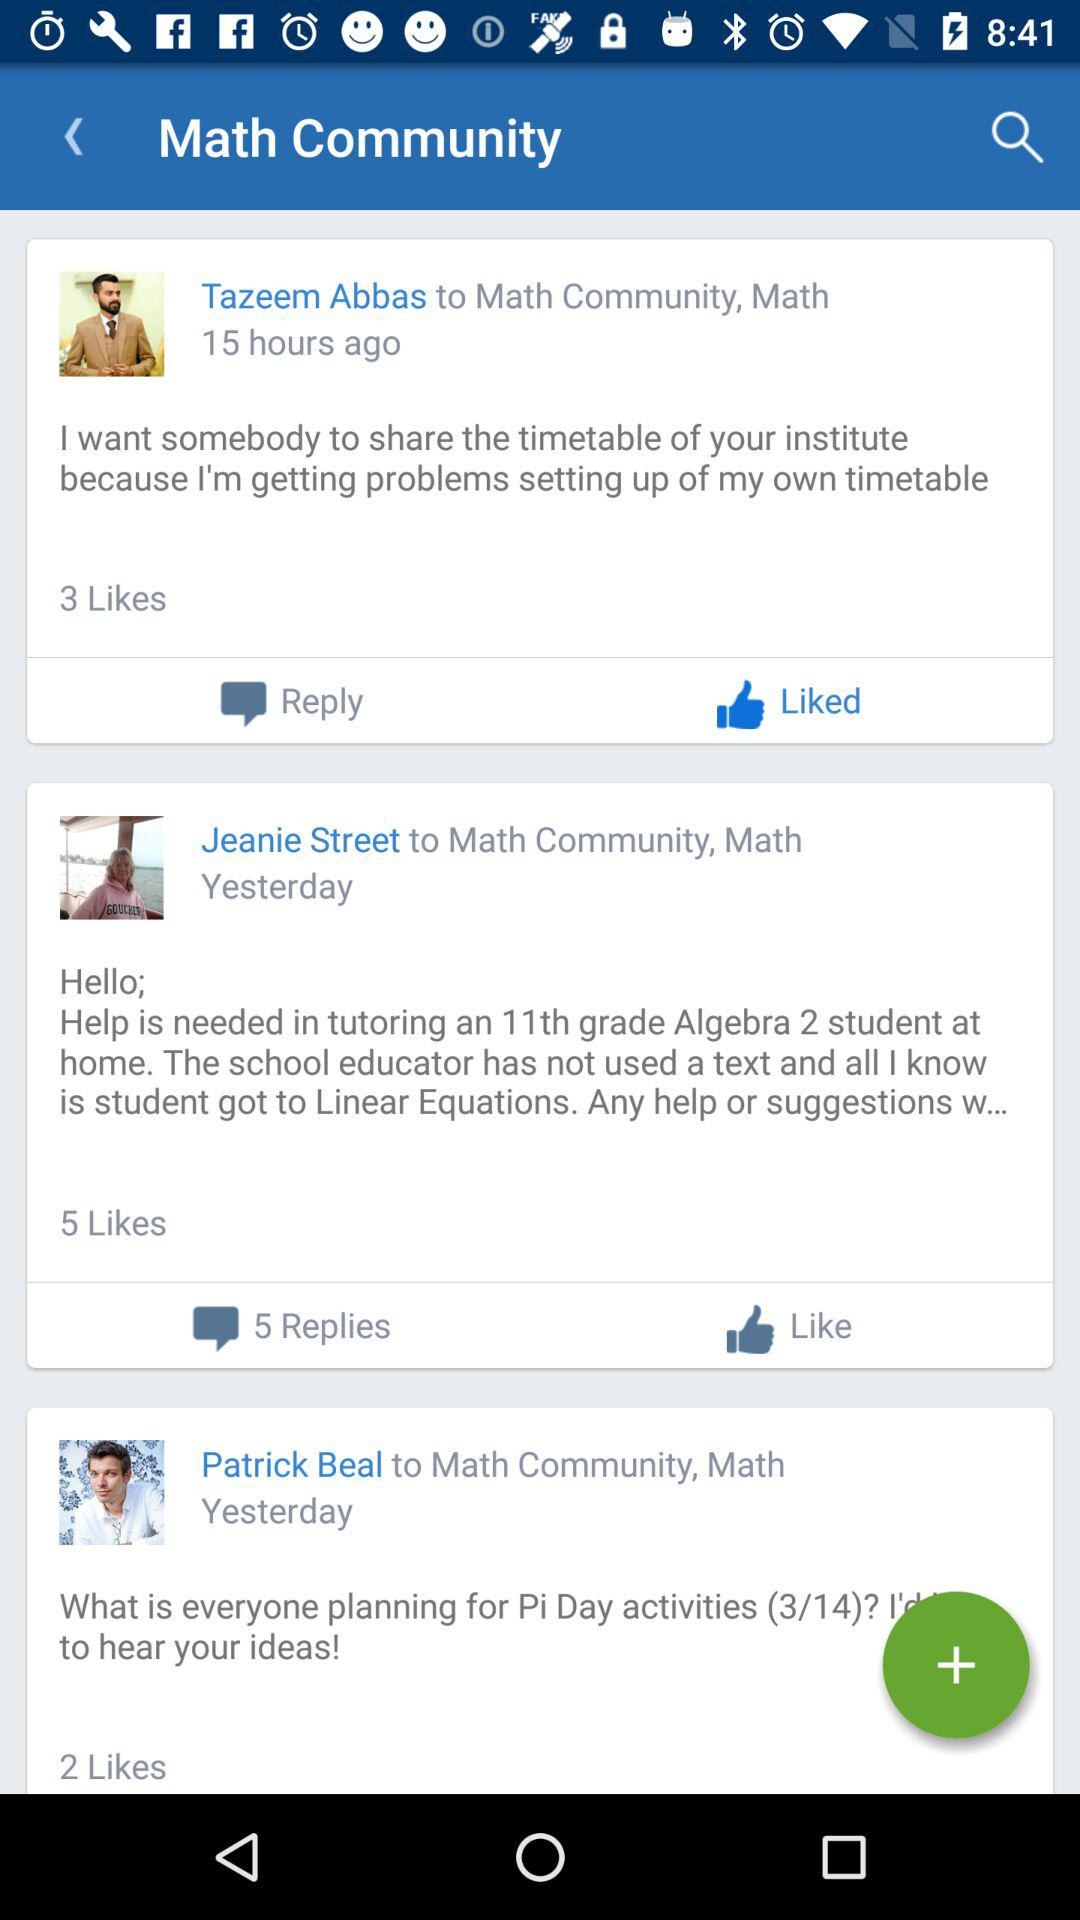How many more likes does the post by Jeanie Street have than Patrick Beal?
Answer the question using a single word or phrase. 3 